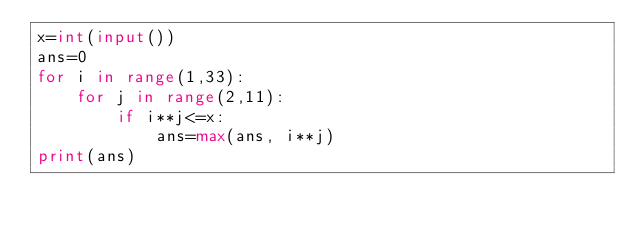<code> <loc_0><loc_0><loc_500><loc_500><_Python_>x=int(input())
ans=0
for i in range(1,33):
    for j in range(2,11):
        if i**j<=x:
            ans=max(ans, i**j)
print(ans)</code> 